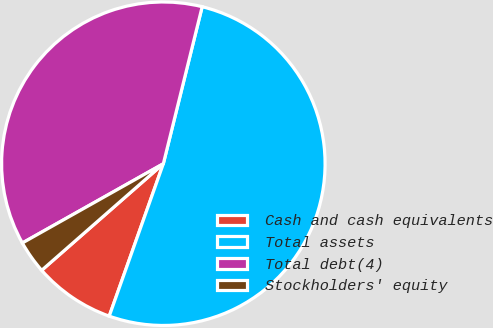<chart> <loc_0><loc_0><loc_500><loc_500><pie_chart><fcel>Cash and cash equivalents<fcel>Total assets<fcel>Total debt(4)<fcel>Stockholders' equity<nl><fcel>8.12%<fcel>51.57%<fcel>37.01%<fcel>3.3%<nl></chart> 